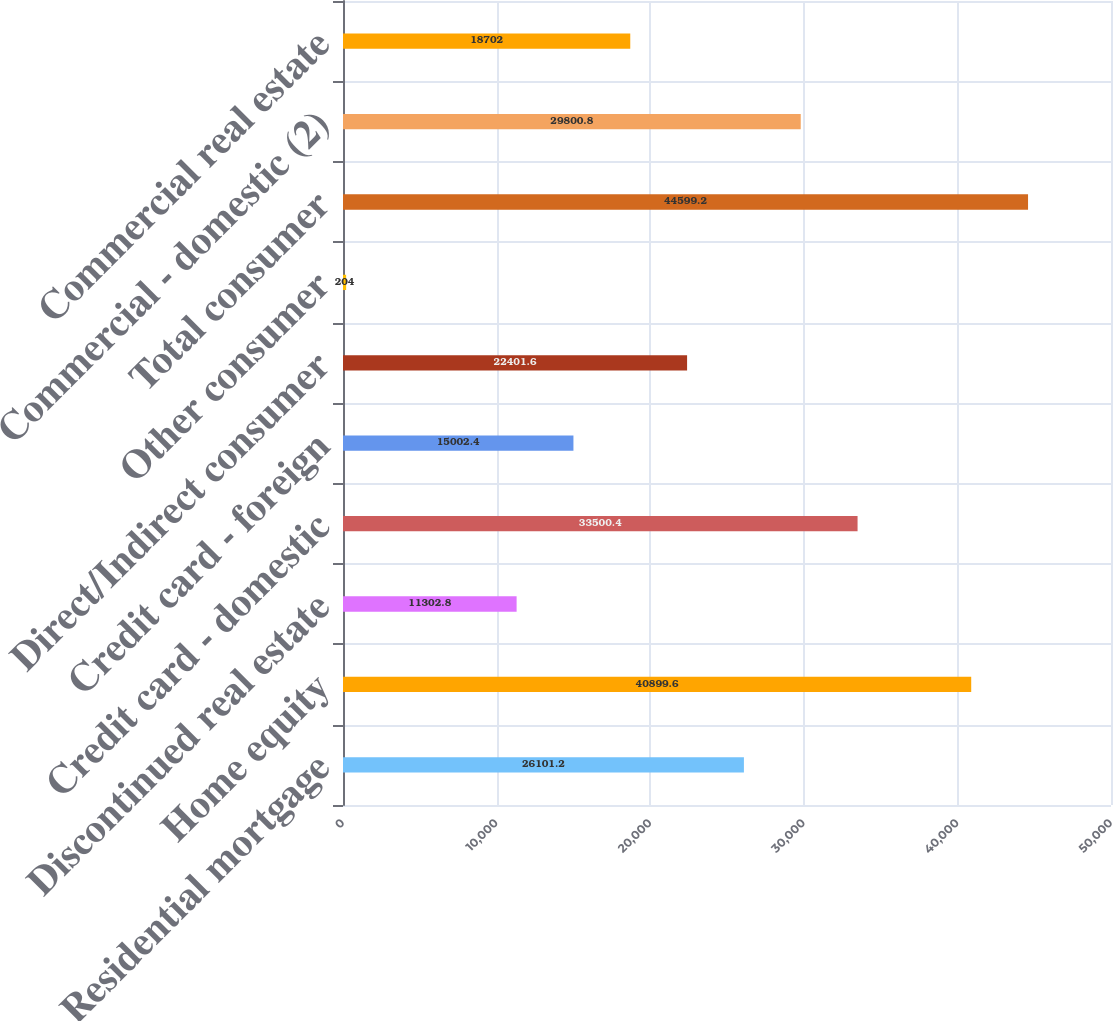<chart> <loc_0><loc_0><loc_500><loc_500><bar_chart><fcel>Residential mortgage<fcel>Home equity<fcel>Discontinued real estate<fcel>Credit card - domestic<fcel>Credit card - foreign<fcel>Direct/Indirect consumer<fcel>Other consumer<fcel>Total consumer<fcel>Commercial - domestic (2)<fcel>Commercial real estate<nl><fcel>26101.2<fcel>40899.6<fcel>11302.8<fcel>33500.4<fcel>15002.4<fcel>22401.6<fcel>204<fcel>44599.2<fcel>29800.8<fcel>18702<nl></chart> 